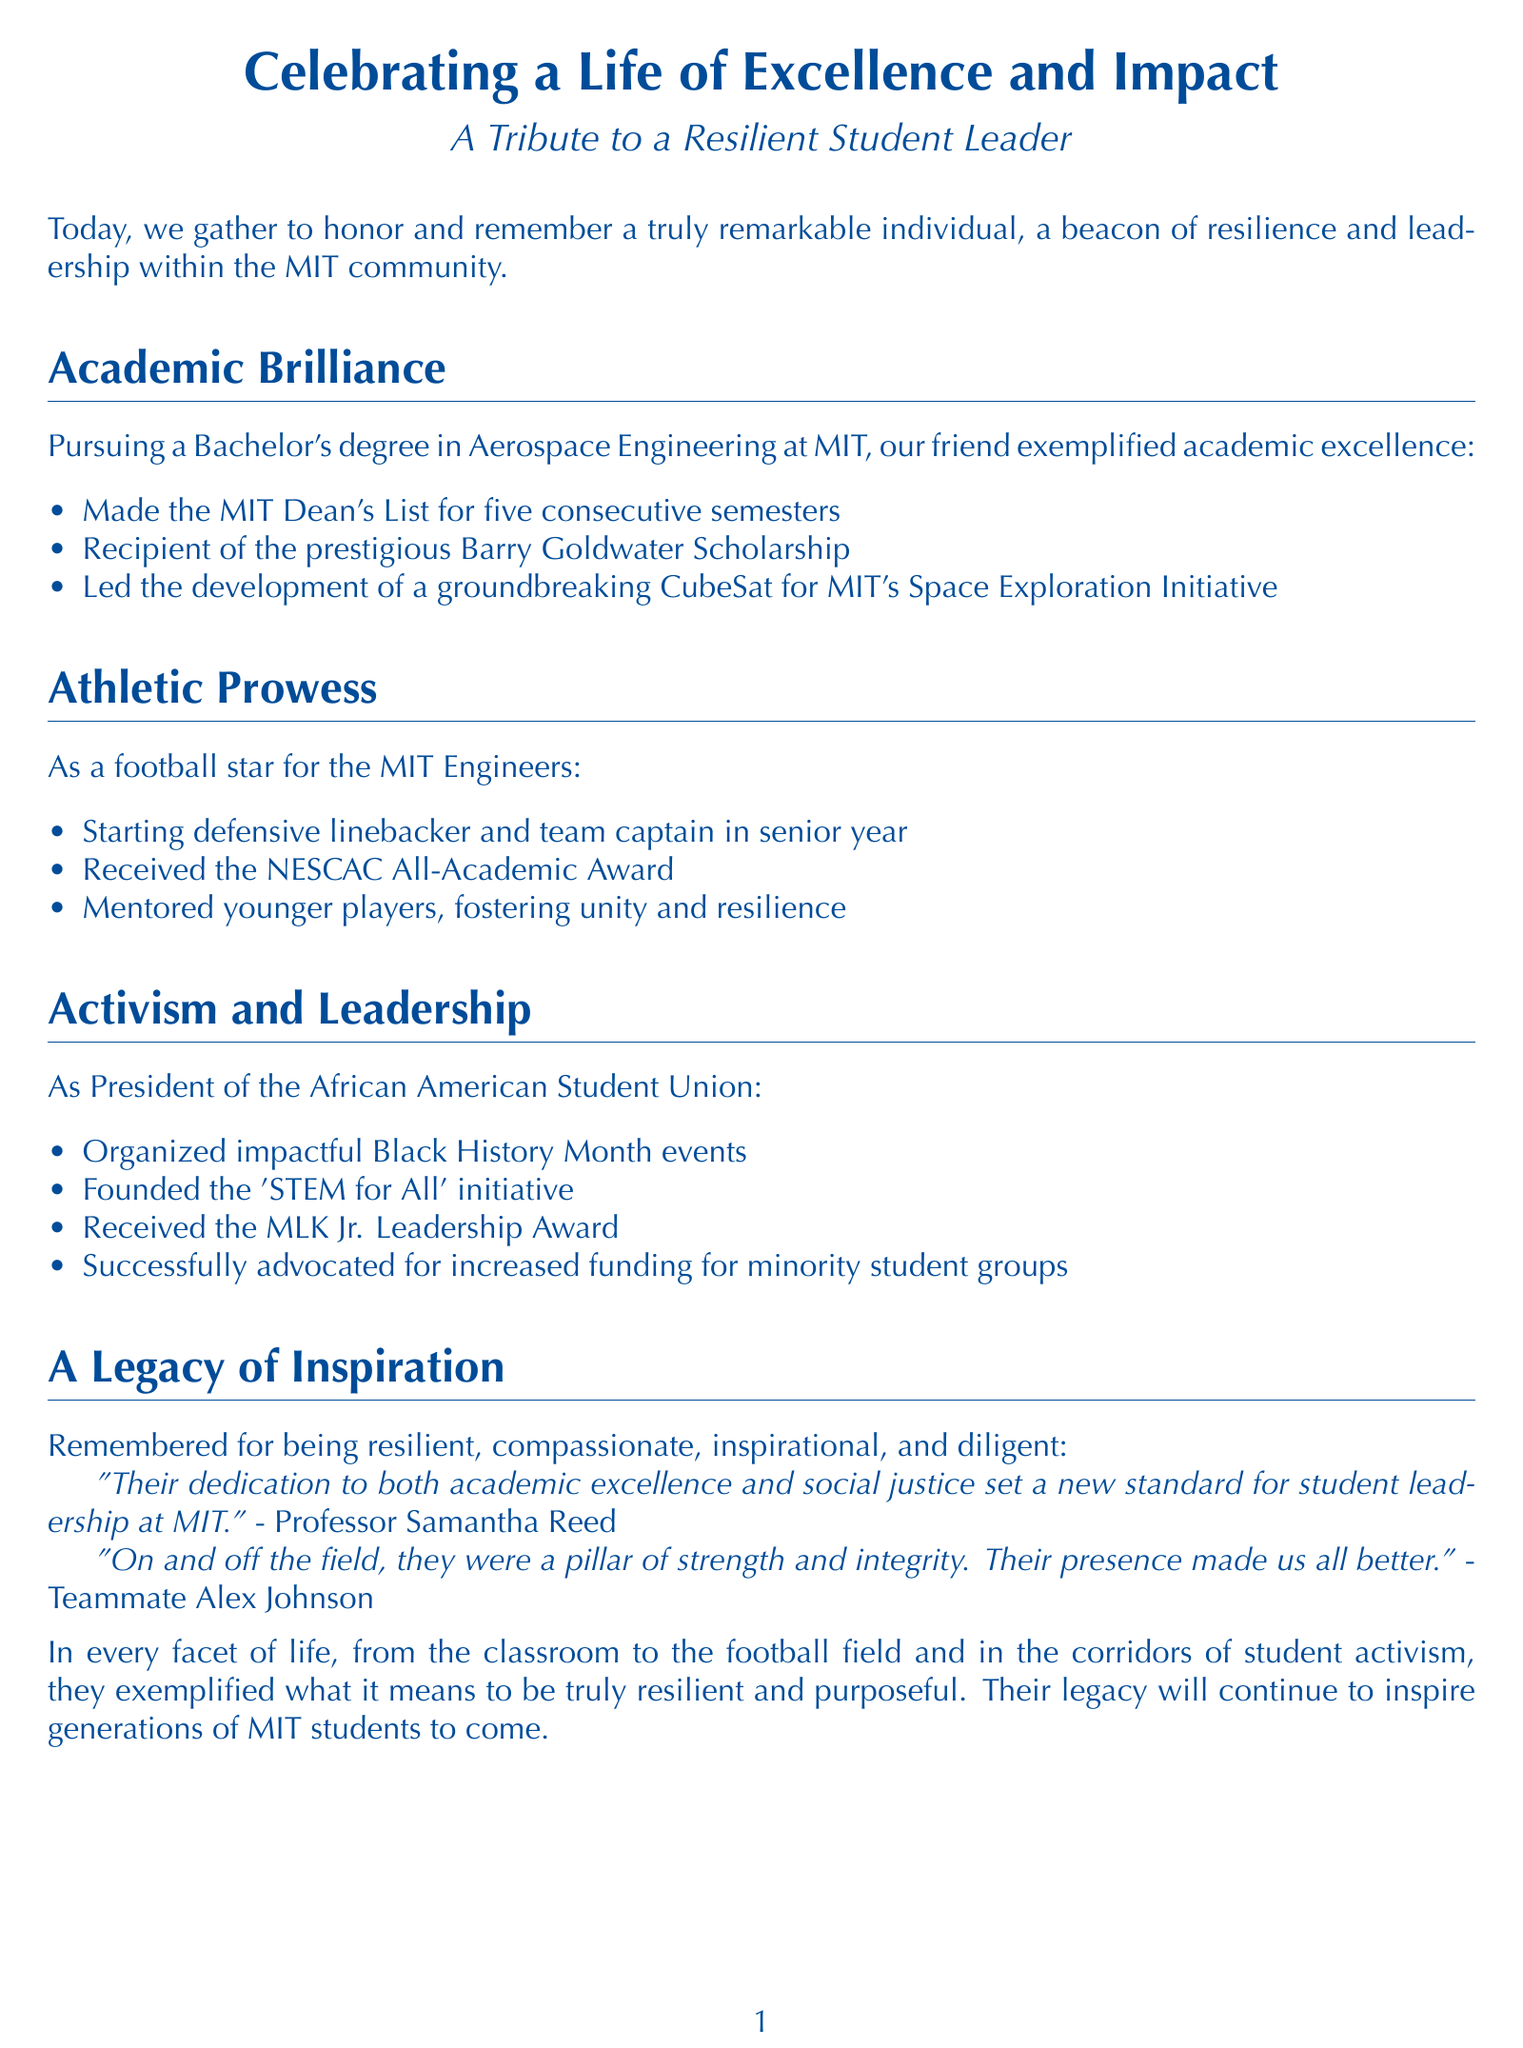What degree did they pursue? The document states that they were pursuing a Bachelor's degree in Aerospace Engineering.
Answer: Aerospace Engineering How many semesters did they make the Dean's List? The document specifies that they made the Dean's List for five consecutive semesters.
Answer: five What position did they play in football? The document indicates that they were a starting defensive linebacker.
Answer: defensive linebacker What initiative did they found as President of the African American Student Union? The document mentions that they founded the 'STEM for All' initiative.
Answer: 'STEM for All' Which award did they receive for their leadership? The document notes that they received the MLK Jr. Leadership Award.
Answer: MLK Jr. Leadership Award What collective impact did their efforts have on MIT? The document highlights that their actions set a new standard for student leadership at MIT.
Answer: new standard How would their teammates describe their on-field presence? The document mentions that their presence made their teammates all better.
Answer: made us all better What scholarship did they receive? The document states that they were a recipient of the prestigious Barry Goldwater Scholarship.
Answer: Barry Goldwater Scholarship 